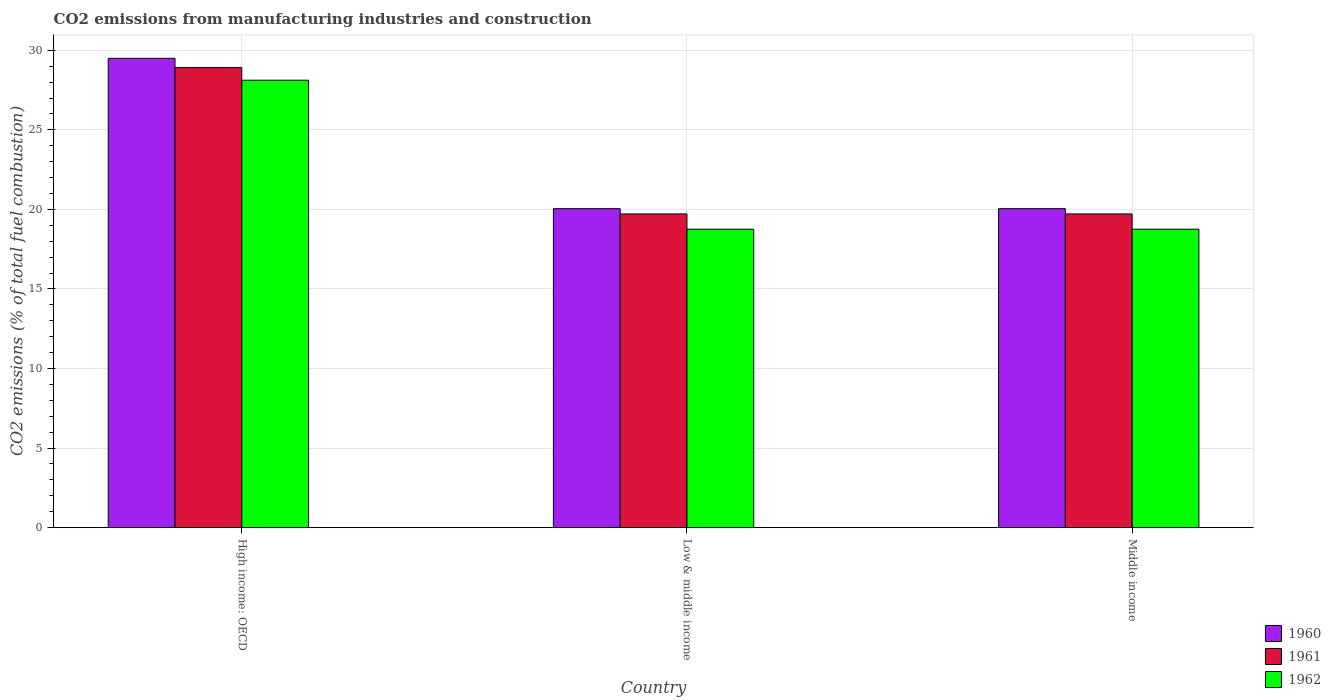How many different coloured bars are there?
Your response must be concise. 3. How many groups of bars are there?
Your response must be concise. 3. Are the number of bars per tick equal to the number of legend labels?
Give a very brief answer. Yes. What is the label of the 1st group of bars from the left?
Provide a succinct answer. High income: OECD. In how many cases, is the number of bars for a given country not equal to the number of legend labels?
Your answer should be very brief. 0. What is the amount of CO2 emitted in 1962 in Middle income?
Keep it short and to the point. 18.76. Across all countries, what is the maximum amount of CO2 emitted in 1962?
Make the answer very short. 28.12. Across all countries, what is the minimum amount of CO2 emitted in 1961?
Keep it short and to the point. 19.72. In which country was the amount of CO2 emitted in 1961 maximum?
Offer a terse response. High income: OECD. What is the total amount of CO2 emitted in 1961 in the graph?
Offer a terse response. 68.35. What is the difference between the amount of CO2 emitted in 1961 in Low & middle income and that in Middle income?
Your response must be concise. 0. What is the difference between the amount of CO2 emitted in 1961 in Middle income and the amount of CO2 emitted in 1960 in High income: OECD?
Your answer should be very brief. -9.78. What is the average amount of CO2 emitted in 1961 per country?
Make the answer very short. 22.78. What is the difference between the amount of CO2 emitted of/in 1962 and amount of CO2 emitted of/in 1961 in Low & middle income?
Make the answer very short. -0.96. In how many countries, is the amount of CO2 emitted in 1960 greater than 25 %?
Offer a terse response. 1. What is the ratio of the amount of CO2 emitted in 1962 in High income: OECD to that in Middle income?
Keep it short and to the point. 1.5. Is the amount of CO2 emitted in 1962 in High income: OECD less than that in Middle income?
Your answer should be compact. No. What is the difference between the highest and the second highest amount of CO2 emitted in 1961?
Provide a succinct answer. -9.2. What is the difference between the highest and the lowest amount of CO2 emitted in 1960?
Your answer should be very brief. 9.45. In how many countries, is the amount of CO2 emitted in 1961 greater than the average amount of CO2 emitted in 1961 taken over all countries?
Provide a short and direct response. 1. Are all the bars in the graph horizontal?
Offer a very short reply. No. Does the graph contain any zero values?
Offer a very short reply. No. Does the graph contain grids?
Provide a short and direct response. Yes. How many legend labels are there?
Provide a short and direct response. 3. What is the title of the graph?
Give a very brief answer. CO2 emissions from manufacturing industries and construction. Does "1967" appear as one of the legend labels in the graph?
Keep it short and to the point. No. What is the label or title of the X-axis?
Your response must be concise. Country. What is the label or title of the Y-axis?
Provide a short and direct response. CO2 emissions (% of total fuel combustion). What is the CO2 emissions (% of total fuel combustion) in 1960 in High income: OECD?
Offer a terse response. 29.5. What is the CO2 emissions (% of total fuel combustion) of 1961 in High income: OECD?
Make the answer very short. 28.92. What is the CO2 emissions (% of total fuel combustion) of 1962 in High income: OECD?
Offer a terse response. 28.12. What is the CO2 emissions (% of total fuel combustion) of 1960 in Low & middle income?
Offer a terse response. 20.05. What is the CO2 emissions (% of total fuel combustion) in 1961 in Low & middle income?
Offer a terse response. 19.72. What is the CO2 emissions (% of total fuel combustion) of 1962 in Low & middle income?
Your answer should be compact. 18.76. What is the CO2 emissions (% of total fuel combustion) of 1960 in Middle income?
Your answer should be compact. 20.05. What is the CO2 emissions (% of total fuel combustion) in 1961 in Middle income?
Your response must be concise. 19.72. What is the CO2 emissions (% of total fuel combustion) in 1962 in Middle income?
Offer a very short reply. 18.76. Across all countries, what is the maximum CO2 emissions (% of total fuel combustion) of 1960?
Provide a succinct answer. 29.5. Across all countries, what is the maximum CO2 emissions (% of total fuel combustion) in 1961?
Make the answer very short. 28.92. Across all countries, what is the maximum CO2 emissions (% of total fuel combustion) in 1962?
Keep it short and to the point. 28.12. Across all countries, what is the minimum CO2 emissions (% of total fuel combustion) of 1960?
Offer a terse response. 20.05. Across all countries, what is the minimum CO2 emissions (% of total fuel combustion) in 1961?
Your answer should be very brief. 19.72. Across all countries, what is the minimum CO2 emissions (% of total fuel combustion) of 1962?
Your answer should be very brief. 18.76. What is the total CO2 emissions (% of total fuel combustion) of 1960 in the graph?
Provide a short and direct response. 69.59. What is the total CO2 emissions (% of total fuel combustion) of 1961 in the graph?
Your response must be concise. 68.35. What is the total CO2 emissions (% of total fuel combustion) in 1962 in the graph?
Make the answer very short. 65.64. What is the difference between the CO2 emissions (% of total fuel combustion) of 1960 in High income: OECD and that in Low & middle income?
Make the answer very short. 9.45. What is the difference between the CO2 emissions (% of total fuel combustion) of 1961 in High income: OECD and that in Low & middle income?
Provide a succinct answer. 9.2. What is the difference between the CO2 emissions (% of total fuel combustion) in 1962 in High income: OECD and that in Low & middle income?
Your answer should be very brief. 9.37. What is the difference between the CO2 emissions (% of total fuel combustion) in 1960 in High income: OECD and that in Middle income?
Your answer should be compact. 9.45. What is the difference between the CO2 emissions (% of total fuel combustion) in 1961 in High income: OECD and that in Middle income?
Give a very brief answer. 9.2. What is the difference between the CO2 emissions (% of total fuel combustion) of 1962 in High income: OECD and that in Middle income?
Your response must be concise. 9.37. What is the difference between the CO2 emissions (% of total fuel combustion) of 1962 in Low & middle income and that in Middle income?
Provide a short and direct response. 0. What is the difference between the CO2 emissions (% of total fuel combustion) in 1960 in High income: OECD and the CO2 emissions (% of total fuel combustion) in 1961 in Low & middle income?
Provide a succinct answer. 9.78. What is the difference between the CO2 emissions (% of total fuel combustion) in 1960 in High income: OECD and the CO2 emissions (% of total fuel combustion) in 1962 in Low & middle income?
Your answer should be very brief. 10.74. What is the difference between the CO2 emissions (% of total fuel combustion) in 1961 in High income: OECD and the CO2 emissions (% of total fuel combustion) in 1962 in Low & middle income?
Your answer should be compact. 10.16. What is the difference between the CO2 emissions (% of total fuel combustion) of 1960 in High income: OECD and the CO2 emissions (% of total fuel combustion) of 1961 in Middle income?
Your answer should be very brief. 9.78. What is the difference between the CO2 emissions (% of total fuel combustion) in 1960 in High income: OECD and the CO2 emissions (% of total fuel combustion) in 1962 in Middle income?
Make the answer very short. 10.74. What is the difference between the CO2 emissions (% of total fuel combustion) of 1961 in High income: OECD and the CO2 emissions (% of total fuel combustion) of 1962 in Middle income?
Give a very brief answer. 10.16. What is the difference between the CO2 emissions (% of total fuel combustion) in 1960 in Low & middle income and the CO2 emissions (% of total fuel combustion) in 1961 in Middle income?
Offer a terse response. 0.33. What is the difference between the CO2 emissions (% of total fuel combustion) in 1960 in Low & middle income and the CO2 emissions (% of total fuel combustion) in 1962 in Middle income?
Provide a short and direct response. 1.29. What is the difference between the CO2 emissions (% of total fuel combustion) in 1961 in Low & middle income and the CO2 emissions (% of total fuel combustion) in 1962 in Middle income?
Offer a terse response. 0.96. What is the average CO2 emissions (% of total fuel combustion) in 1960 per country?
Your answer should be very brief. 23.2. What is the average CO2 emissions (% of total fuel combustion) in 1961 per country?
Your response must be concise. 22.78. What is the average CO2 emissions (% of total fuel combustion) in 1962 per country?
Keep it short and to the point. 21.88. What is the difference between the CO2 emissions (% of total fuel combustion) of 1960 and CO2 emissions (% of total fuel combustion) of 1961 in High income: OECD?
Offer a very short reply. 0.58. What is the difference between the CO2 emissions (% of total fuel combustion) of 1960 and CO2 emissions (% of total fuel combustion) of 1962 in High income: OECD?
Make the answer very short. 1.37. What is the difference between the CO2 emissions (% of total fuel combustion) of 1961 and CO2 emissions (% of total fuel combustion) of 1962 in High income: OECD?
Make the answer very short. 0.79. What is the difference between the CO2 emissions (% of total fuel combustion) in 1960 and CO2 emissions (% of total fuel combustion) in 1961 in Low & middle income?
Provide a succinct answer. 0.33. What is the difference between the CO2 emissions (% of total fuel combustion) of 1960 and CO2 emissions (% of total fuel combustion) of 1962 in Low & middle income?
Give a very brief answer. 1.29. What is the difference between the CO2 emissions (% of total fuel combustion) in 1961 and CO2 emissions (% of total fuel combustion) in 1962 in Low & middle income?
Your answer should be very brief. 0.96. What is the difference between the CO2 emissions (% of total fuel combustion) of 1960 and CO2 emissions (% of total fuel combustion) of 1961 in Middle income?
Your answer should be compact. 0.33. What is the difference between the CO2 emissions (% of total fuel combustion) in 1960 and CO2 emissions (% of total fuel combustion) in 1962 in Middle income?
Your response must be concise. 1.29. What is the difference between the CO2 emissions (% of total fuel combustion) in 1961 and CO2 emissions (% of total fuel combustion) in 1962 in Middle income?
Ensure brevity in your answer.  0.96. What is the ratio of the CO2 emissions (% of total fuel combustion) of 1960 in High income: OECD to that in Low & middle income?
Provide a short and direct response. 1.47. What is the ratio of the CO2 emissions (% of total fuel combustion) of 1961 in High income: OECD to that in Low & middle income?
Your answer should be very brief. 1.47. What is the ratio of the CO2 emissions (% of total fuel combustion) in 1962 in High income: OECD to that in Low & middle income?
Offer a terse response. 1.5. What is the ratio of the CO2 emissions (% of total fuel combustion) in 1960 in High income: OECD to that in Middle income?
Offer a very short reply. 1.47. What is the ratio of the CO2 emissions (% of total fuel combustion) of 1961 in High income: OECD to that in Middle income?
Your answer should be very brief. 1.47. What is the ratio of the CO2 emissions (% of total fuel combustion) in 1962 in High income: OECD to that in Middle income?
Your answer should be compact. 1.5. What is the ratio of the CO2 emissions (% of total fuel combustion) of 1962 in Low & middle income to that in Middle income?
Your answer should be very brief. 1. What is the difference between the highest and the second highest CO2 emissions (% of total fuel combustion) of 1960?
Offer a terse response. 9.45. What is the difference between the highest and the second highest CO2 emissions (% of total fuel combustion) in 1961?
Keep it short and to the point. 9.2. What is the difference between the highest and the second highest CO2 emissions (% of total fuel combustion) of 1962?
Ensure brevity in your answer.  9.37. What is the difference between the highest and the lowest CO2 emissions (% of total fuel combustion) of 1960?
Your answer should be compact. 9.45. What is the difference between the highest and the lowest CO2 emissions (% of total fuel combustion) of 1961?
Offer a terse response. 9.2. What is the difference between the highest and the lowest CO2 emissions (% of total fuel combustion) in 1962?
Provide a short and direct response. 9.37. 